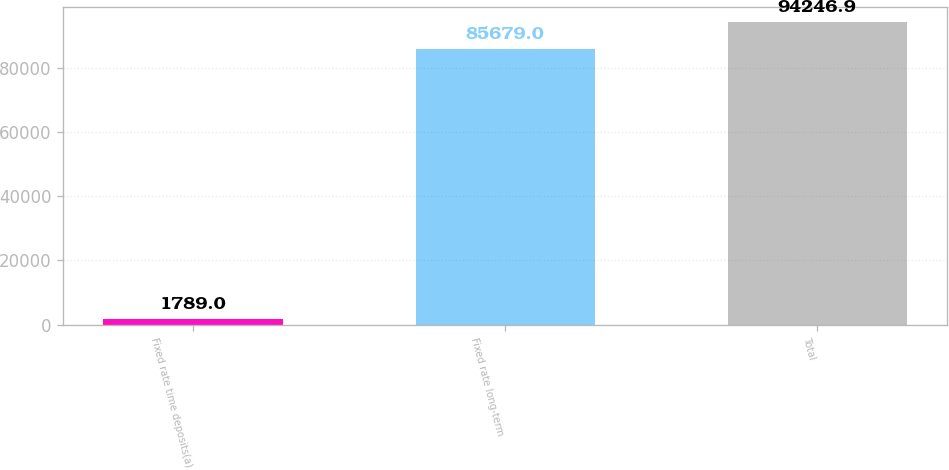Convert chart. <chart><loc_0><loc_0><loc_500><loc_500><bar_chart><fcel>Fixed rate time deposits(a)<fcel>Fixed rate long-term<fcel>Total<nl><fcel>1789<fcel>85679<fcel>94246.9<nl></chart> 